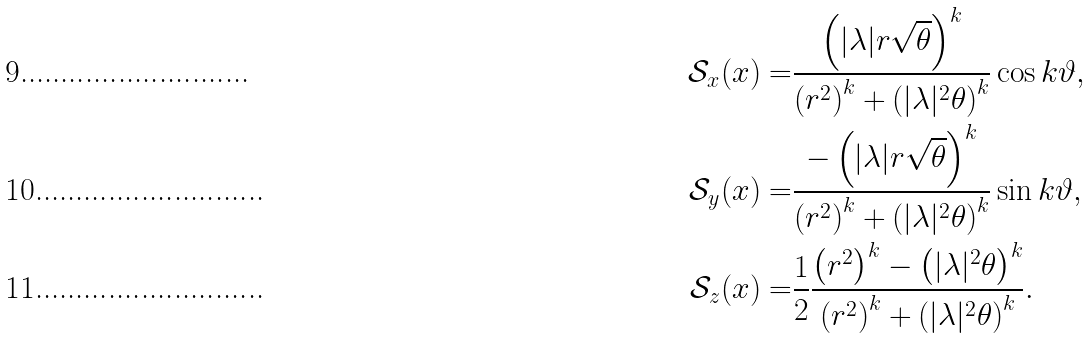Convert formula to latex. <formula><loc_0><loc_0><loc_500><loc_500>\mathcal { S } _ { x } ( x ) = & \frac { \left ( | \lambda | r \sqrt { \theta } \right ) ^ { k } } { \left ( r ^ { 2 } \right ) ^ { k } + \left ( | \lambda | ^ { 2 } \theta \right ) ^ { k } } \cos k \vartheta , \\ \mathcal { S } _ { y } ( x ) = & \frac { - \left ( | \lambda | r \sqrt { \theta } \right ) ^ { k } } { \left ( r ^ { 2 } \right ) ^ { k } + \left ( | \lambda | ^ { 2 } \theta \right ) ^ { k } } \sin k \vartheta , \\ \mathcal { S } _ { z } ( x ) = & \frac { 1 } { 2 } \frac { \left ( r ^ { 2 } \right ) ^ { k } - \left ( | \lambda | ^ { 2 } \theta \right ) ^ { k } } { \left ( r ^ { 2 } \right ) ^ { k } + \left ( | \lambda | ^ { 2 } \theta \right ) ^ { k } } .</formula> 